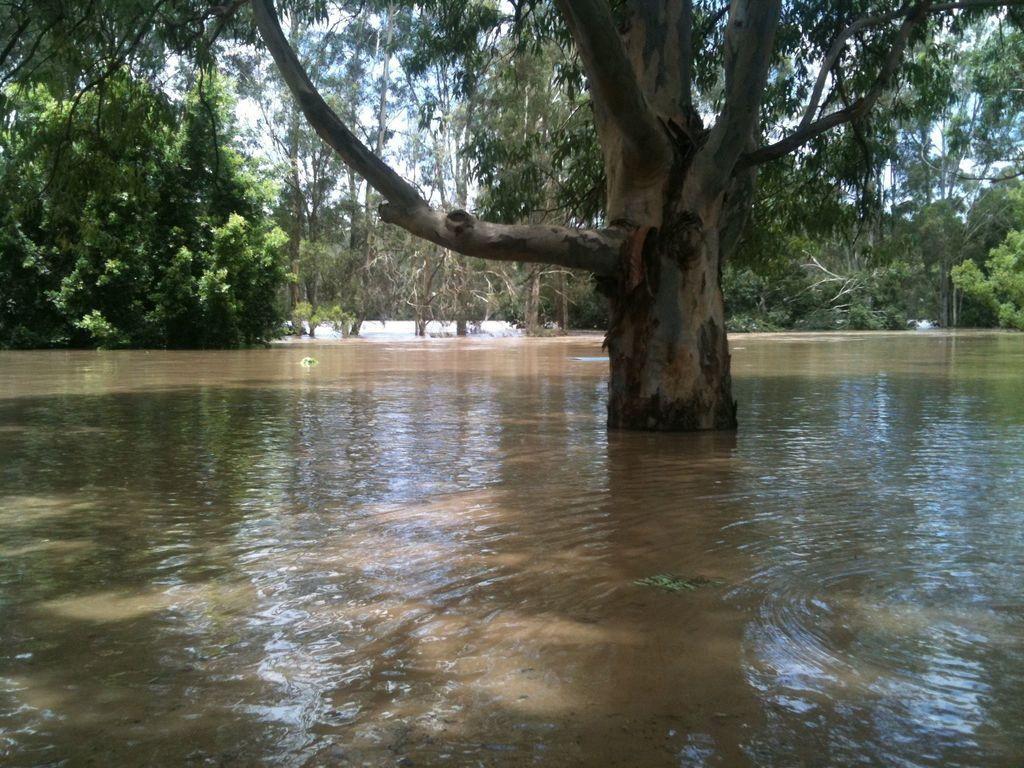How would you summarize this image in a sentence or two? This picture shows trees around and we see water. 